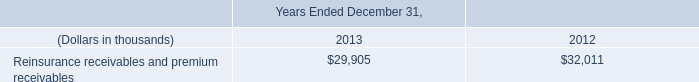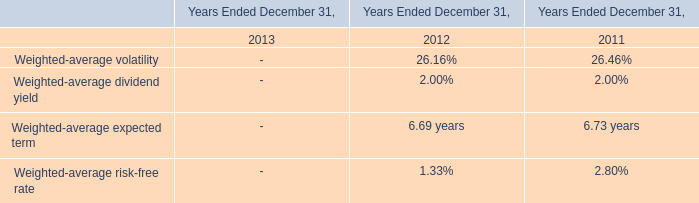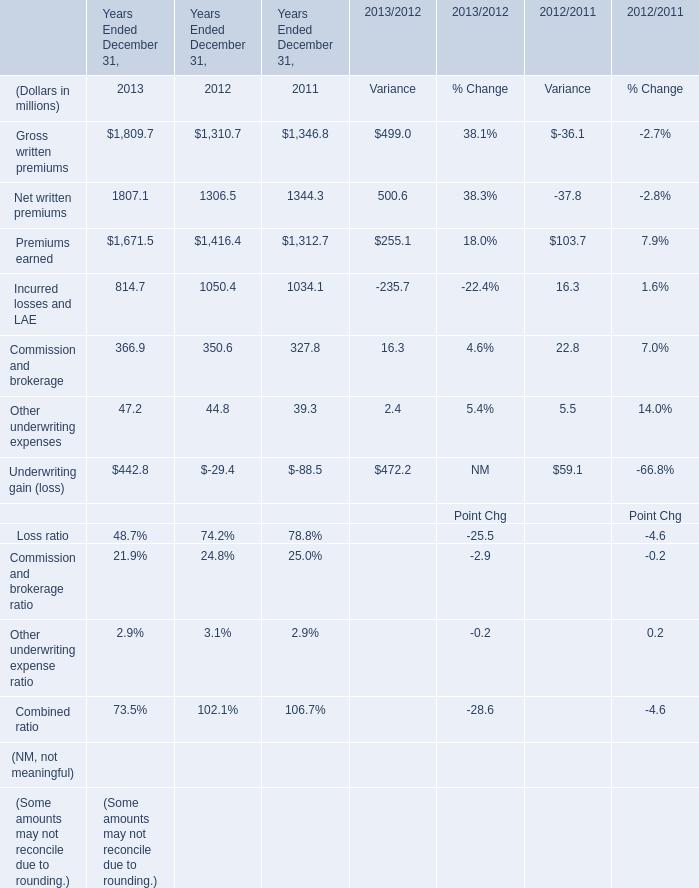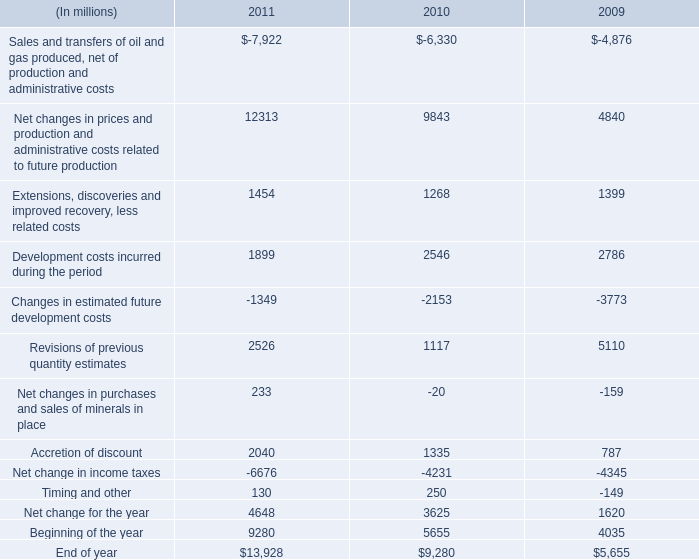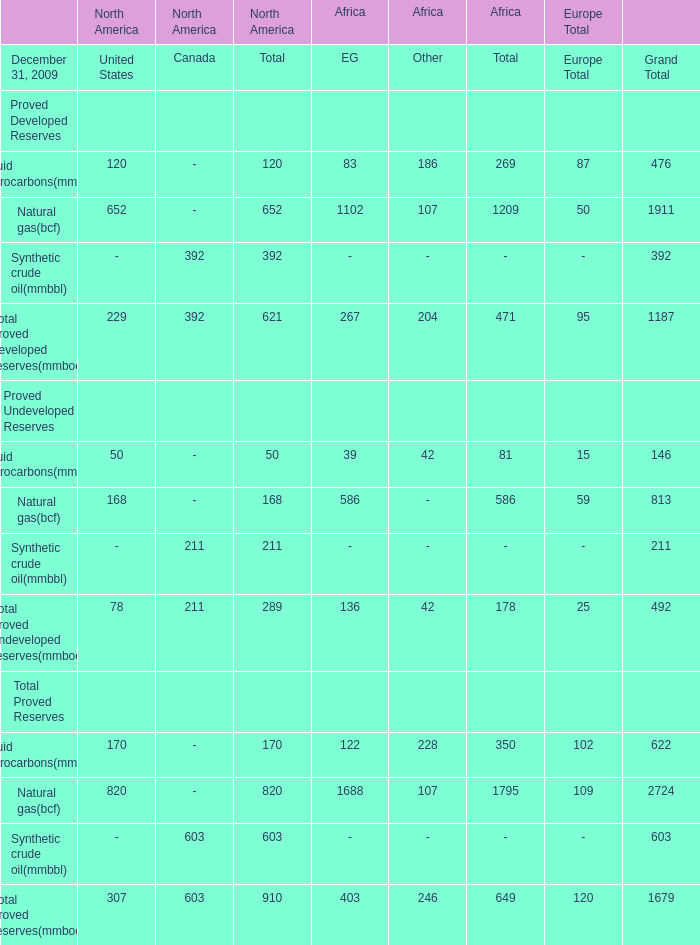What was the total amount of the Total proved undeveloped reserves(mmboe) in the sections where Total proved developed reserves(mmboe) greater than 250? 
Computations: (211 + 136)
Answer: 347.0. 